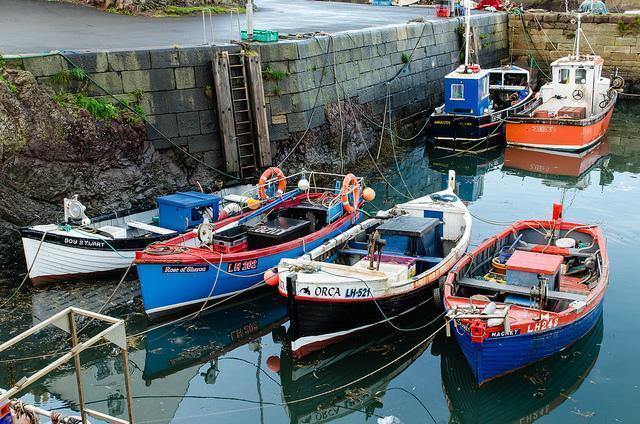How many boats are there?
Give a very brief answer. 6. How many boats are in the photo?
Give a very brief answer. 6. How many donuts have chocolate frosting?
Give a very brief answer. 0. 